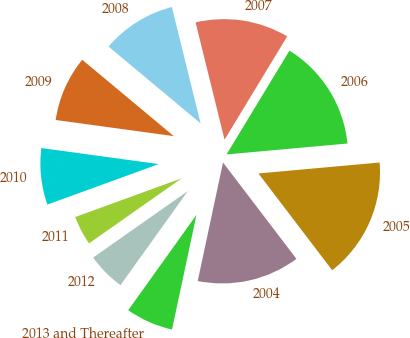<chart> <loc_0><loc_0><loc_500><loc_500><pie_chart><fcel>2004<fcel>2005<fcel>2006<fcel>2007<fcel>2008<fcel>2009<fcel>2010<fcel>2011<fcel>2012<fcel>2013 and Thereafter<nl><fcel>13.71%<fcel>16.07%<fcel>14.89%<fcel>12.53%<fcel>10.08%<fcel>8.9%<fcel>7.72%<fcel>4.19%<fcel>5.37%<fcel>6.54%<nl></chart> 